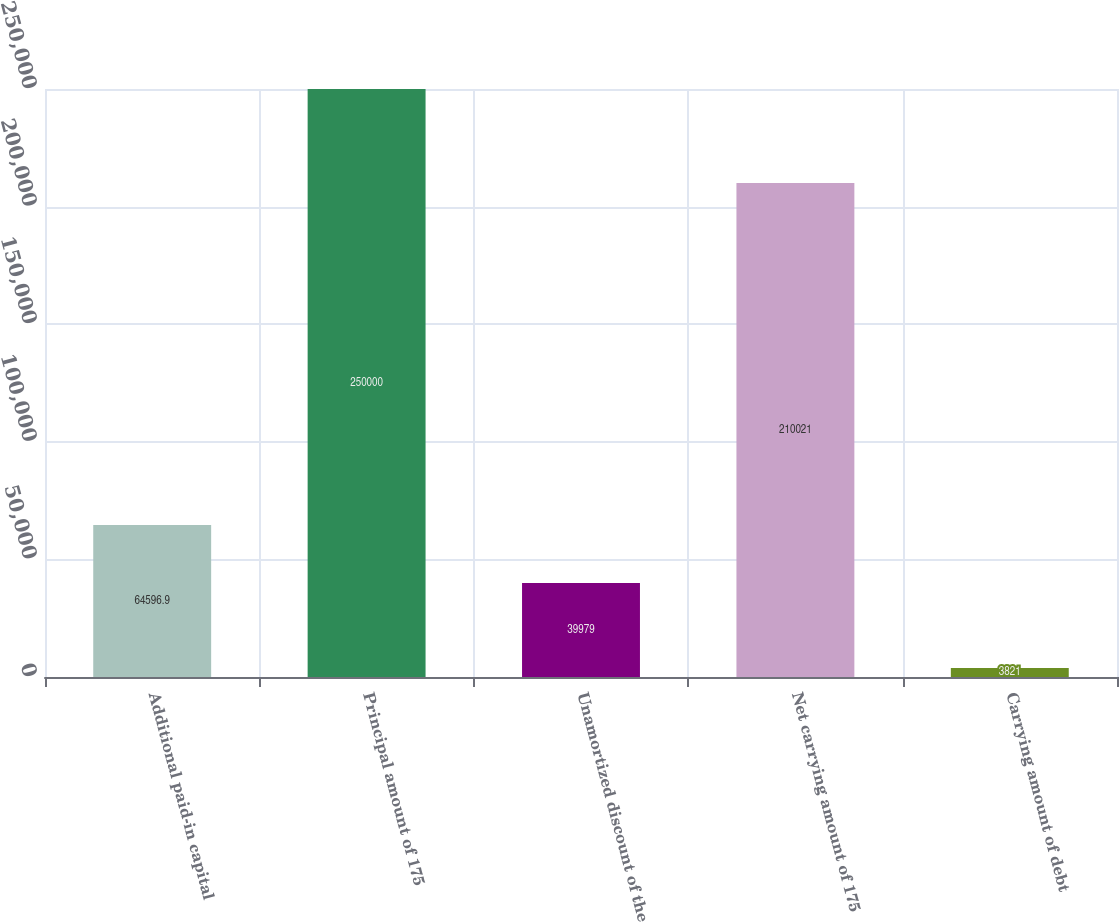<chart> <loc_0><loc_0><loc_500><loc_500><bar_chart><fcel>Additional paid-in capital<fcel>Principal amount of 175<fcel>Unamortized discount of the<fcel>Net carrying amount of 175<fcel>Carrying amount of debt<nl><fcel>64596.9<fcel>250000<fcel>39979<fcel>210021<fcel>3821<nl></chart> 